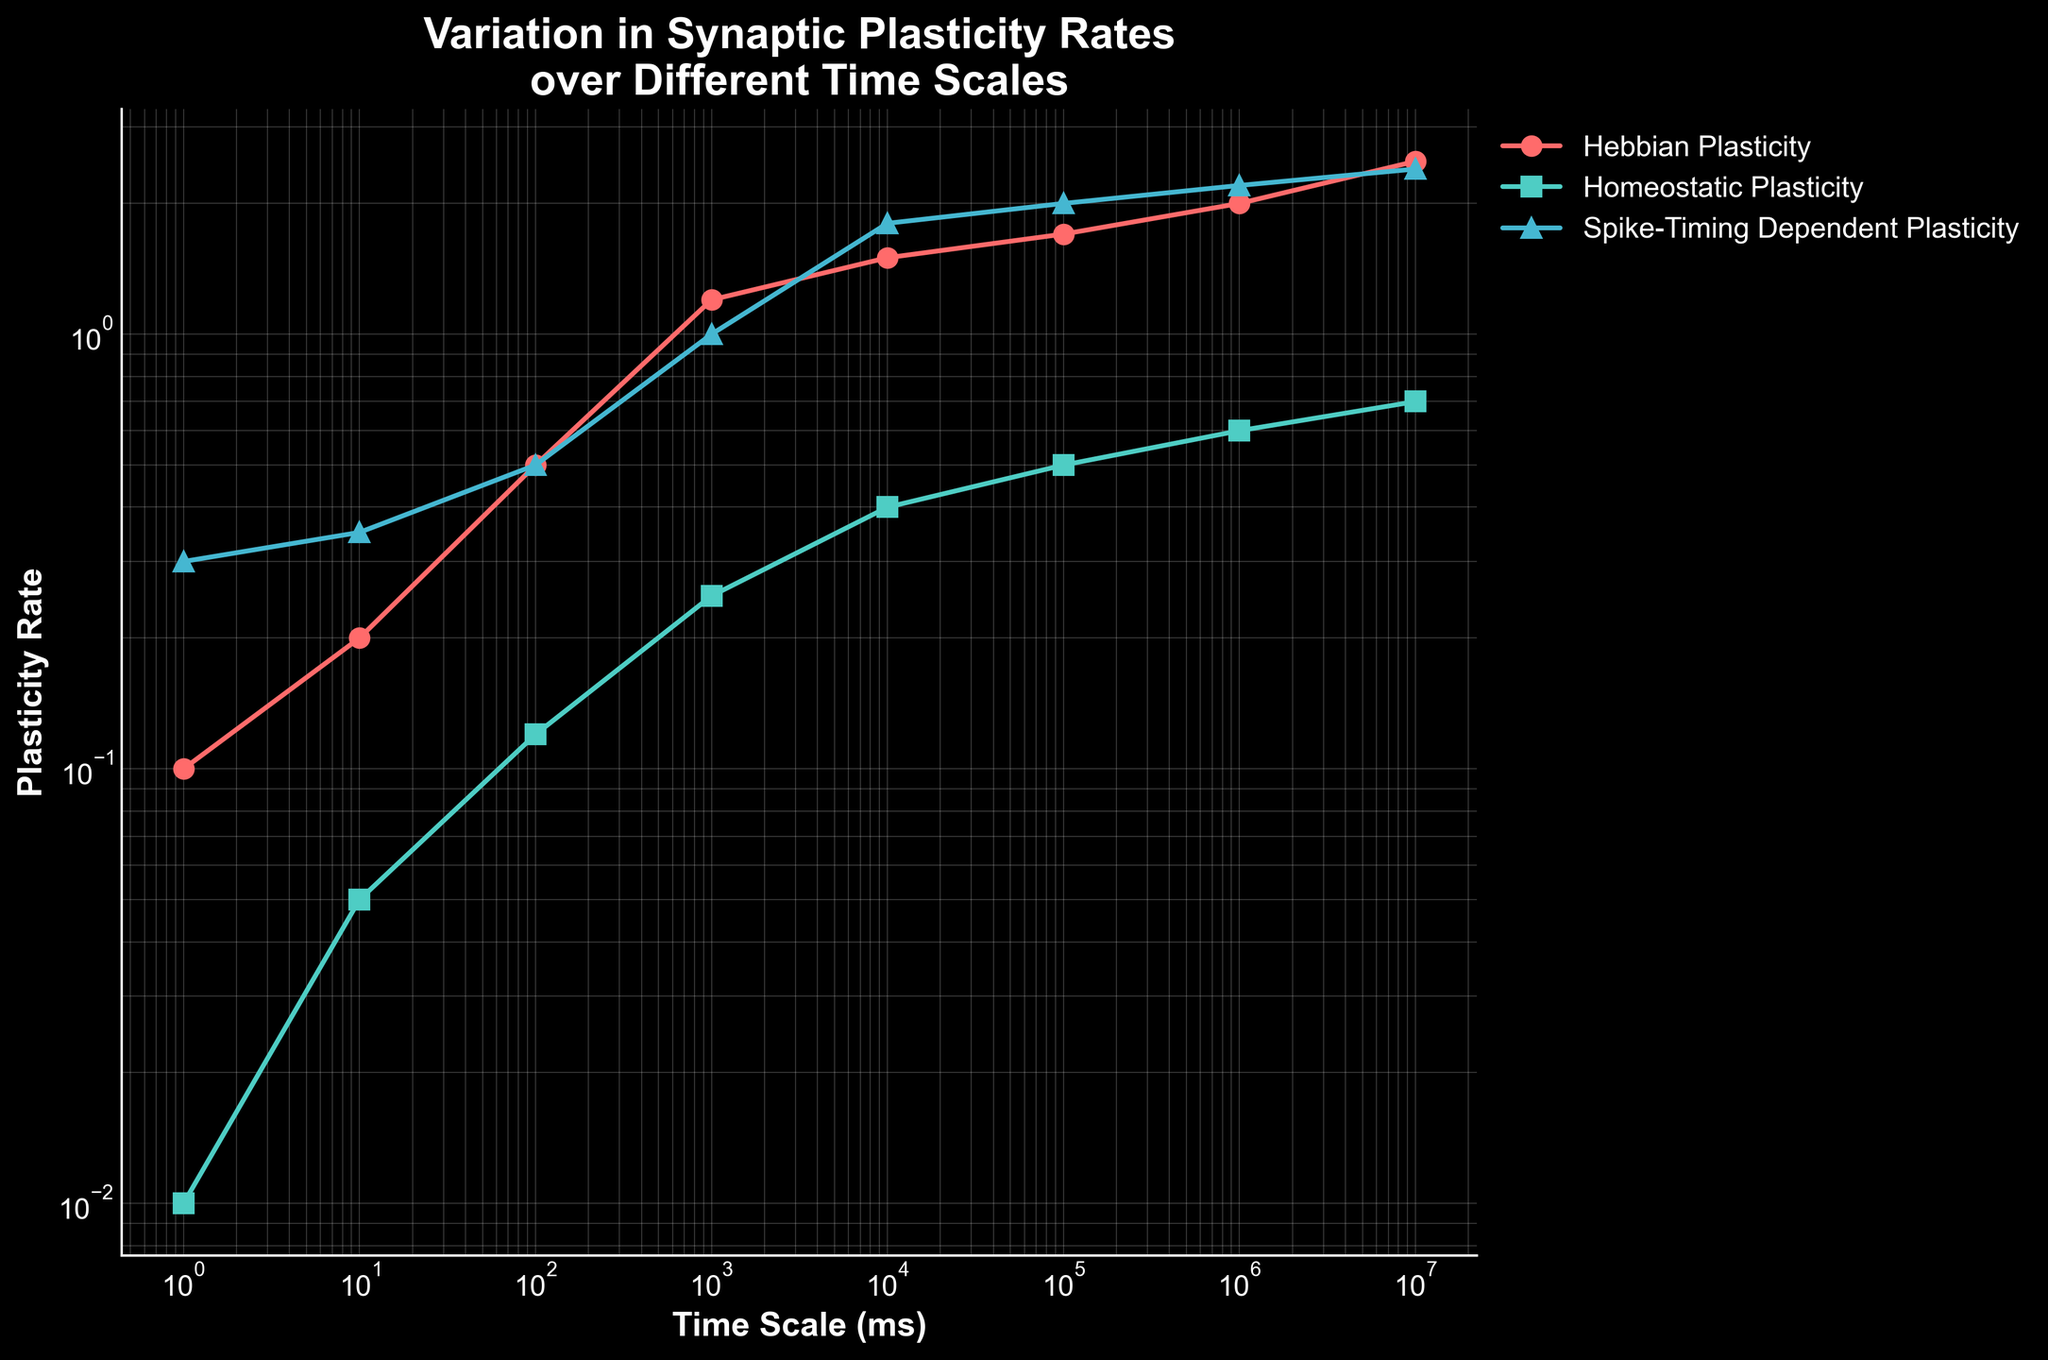What's the title of the figure? The title of the figure can be found at the top, and it reads "Variation in Synaptic Plasticity Rates over Different Time Scales".
Answer: Variation in Synaptic Plasticity Rates over Different Time Scales What is the value of Hebbian Plasticity at a time scale of 10,000 ms? By locating 10,000 ms on the x-axis and reading the corresponding y-value for the Hebbian Plasticity line (red with circle markers), it can be seen to be 1.5.
Answer: 1.5 Which type of plasticity has the highest rate at the largest time scale? At the largest time scale (10,000,000 ms), by comparing the y-values of all three lines, Spike-Timing Dependent Plasticity (blue with triangle markers) has the highest rate.
Answer: Spike-Timing Dependent Plasticity How many different types of plasticity are depicted in the figure? By counting the legend labels, there are three types of plasticity depicted in the figure: Hebbian Plasticity, Homeostatic Plasticity, and Spike-Timing Dependent Plasticity.
Answer: Three At which time scale do all the plasticity rates cross or meet the same value? By examining the plotted lines, all three plasticity rates cross or meet at around 1,000 ms.
Answer: 1,000 ms How does the rate of Homeostatic Plasticity at 1,000 ms compare to Hebbian Plasticity at the same time scale? At 1,000 ms, the rate for Hebbian Plasticity is 1.2, while Homeostatic Plasticity is at 0.25. Hebbian is thus greater than Homeostatic.
Answer: Hebbian is greater Which plasticity type shows the most rapid increase over the entire time scale? By observing the slopes of the lines over the plotted x-axis range, Hebbian Plasticity shows the most rapid increase.
Answer: Hebbian Plasticity Calculate the difference in Spike-Timing Dependent Plasticity rates between 1 ms and 1,000 ms. By reading the values off the plot, the rate at 1 ms is 0.3 and at 1,000 ms is 1.0. The difference is thus \(1.0 - 0.3 = 0.7\).
Answer: 0.7 What is the average plasticity rate for Homeostatic Plasticity at time scales of 10 ms, 1,000 ms, and 1,000,000 ms? Summing the rates: 0.05 (10 ms) + 0.25 (1,000 ms) + 0.6 (1,000,000 ms) and dividing by 3: \((0.05 + 0.25 + 0.6)/3 = 0.3\).
Answer: 0.3 